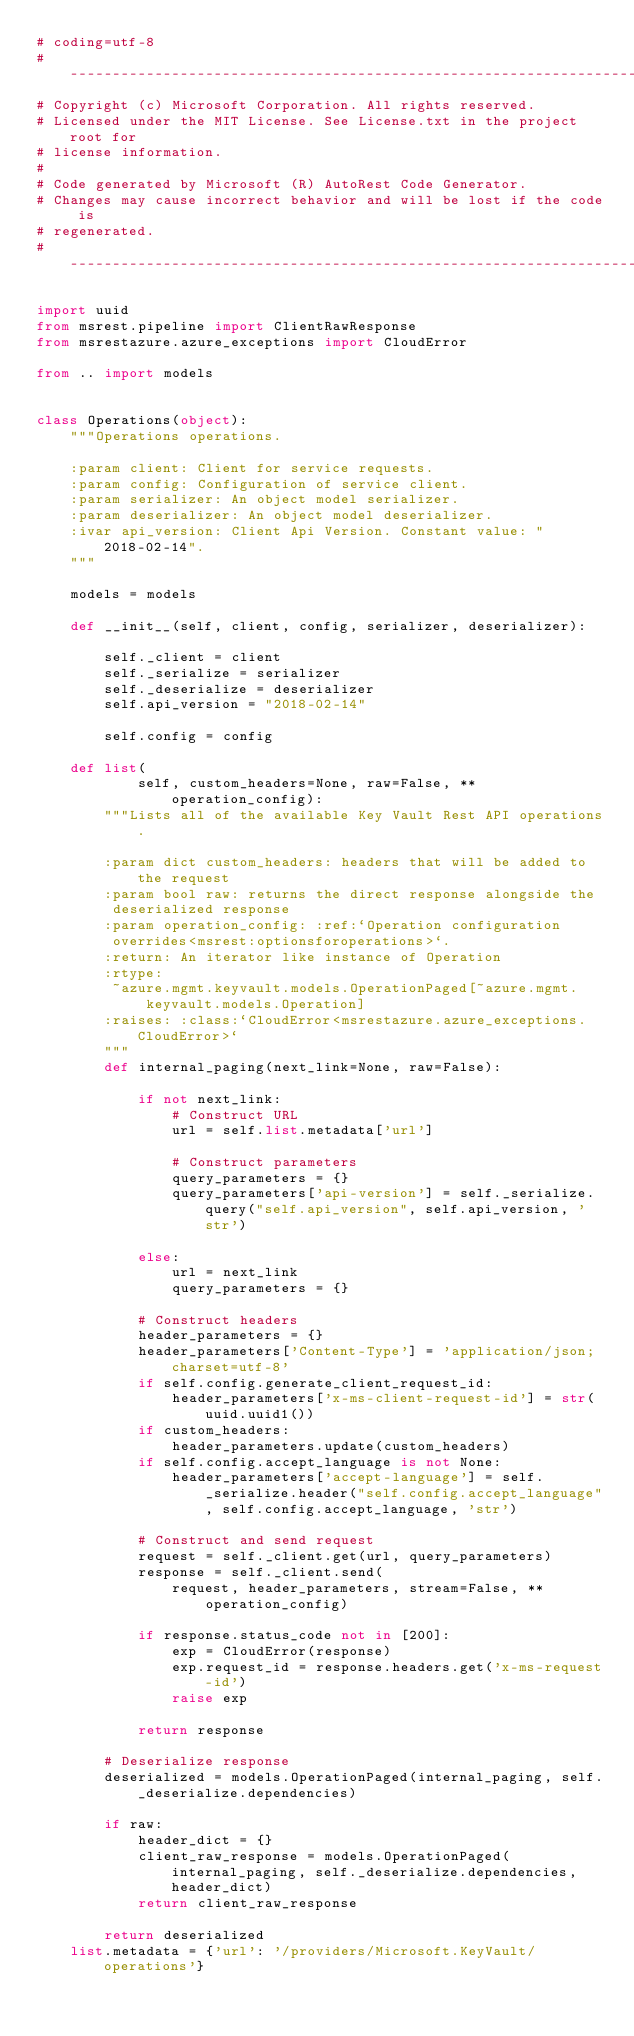<code> <loc_0><loc_0><loc_500><loc_500><_Python_># coding=utf-8
# --------------------------------------------------------------------------
# Copyright (c) Microsoft Corporation. All rights reserved.
# Licensed under the MIT License. See License.txt in the project root for
# license information.
#
# Code generated by Microsoft (R) AutoRest Code Generator.
# Changes may cause incorrect behavior and will be lost if the code is
# regenerated.
# --------------------------------------------------------------------------

import uuid
from msrest.pipeline import ClientRawResponse
from msrestazure.azure_exceptions import CloudError

from .. import models


class Operations(object):
    """Operations operations.

    :param client: Client for service requests.
    :param config: Configuration of service client.
    :param serializer: An object model serializer.
    :param deserializer: An object model deserializer.
    :ivar api_version: Client Api Version. Constant value: "2018-02-14".
    """

    models = models

    def __init__(self, client, config, serializer, deserializer):

        self._client = client
        self._serialize = serializer
        self._deserialize = deserializer
        self.api_version = "2018-02-14"

        self.config = config

    def list(
            self, custom_headers=None, raw=False, **operation_config):
        """Lists all of the available Key Vault Rest API operations.

        :param dict custom_headers: headers that will be added to the request
        :param bool raw: returns the direct response alongside the
         deserialized response
        :param operation_config: :ref:`Operation configuration
         overrides<msrest:optionsforoperations>`.
        :return: An iterator like instance of Operation
        :rtype:
         ~azure.mgmt.keyvault.models.OperationPaged[~azure.mgmt.keyvault.models.Operation]
        :raises: :class:`CloudError<msrestazure.azure_exceptions.CloudError>`
        """
        def internal_paging(next_link=None, raw=False):

            if not next_link:
                # Construct URL
                url = self.list.metadata['url']

                # Construct parameters
                query_parameters = {}
                query_parameters['api-version'] = self._serialize.query("self.api_version", self.api_version, 'str')

            else:
                url = next_link
                query_parameters = {}

            # Construct headers
            header_parameters = {}
            header_parameters['Content-Type'] = 'application/json; charset=utf-8'
            if self.config.generate_client_request_id:
                header_parameters['x-ms-client-request-id'] = str(uuid.uuid1())
            if custom_headers:
                header_parameters.update(custom_headers)
            if self.config.accept_language is not None:
                header_parameters['accept-language'] = self._serialize.header("self.config.accept_language", self.config.accept_language, 'str')

            # Construct and send request
            request = self._client.get(url, query_parameters)
            response = self._client.send(
                request, header_parameters, stream=False, **operation_config)

            if response.status_code not in [200]:
                exp = CloudError(response)
                exp.request_id = response.headers.get('x-ms-request-id')
                raise exp

            return response

        # Deserialize response
        deserialized = models.OperationPaged(internal_paging, self._deserialize.dependencies)

        if raw:
            header_dict = {}
            client_raw_response = models.OperationPaged(internal_paging, self._deserialize.dependencies, header_dict)
            return client_raw_response

        return deserialized
    list.metadata = {'url': '/providers/Microsoft.KeyVault/operations'}
</code> 